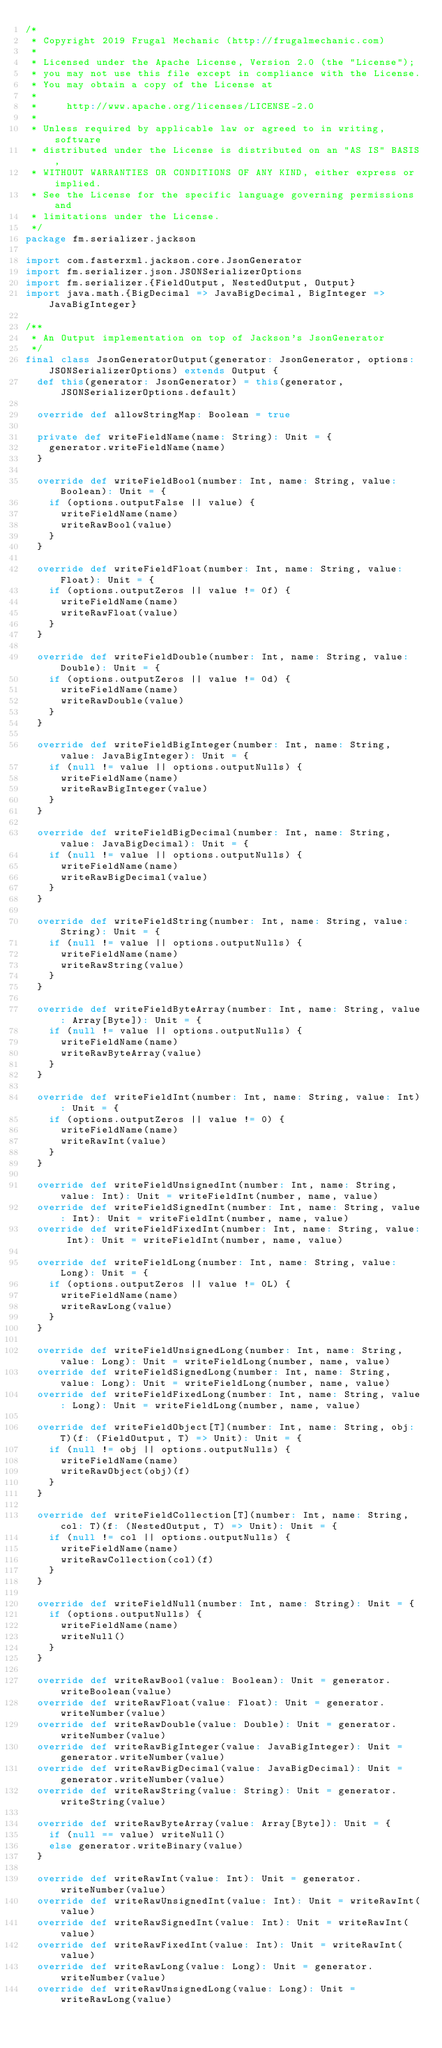Convert code to text. <code><loc_0><loc_0><loc_500><loc_500><_Scala_>/*
 * Copyright 2019 Frugal Mechanic (http://frugalmechanic.com)
 *
 * Licensed under the Apache License, Version 2.0 (the "License");
 * you may not use this file except in compliance with the License.
 * You may obtain a copy of the License at
 *
 *     http://www.apache.org/licenses/LICENSE-2.0
 *
 * Unless required by applicable law or agreed to in writing, software
 * distributed under the License is distributed on an "AS IS" BASIS,
 * WITHOUT WARRANTIES OR CONDITIONS OF ANY KIND, either express or implied.
 * See the License for the specific language governing permissions and
 * limitations under the License.
 */
package fm.serializer.jackson

import com.fasterxml.jackson.core.JsonGenerator
import fm.serializer.json.JSONSerializerOptions
import fm.serializer.{FieldOutput, NestedOutput, Output}
import java.math.{BigDecimal => JavaBigDecimal, BigInteger => JavaBigInteger}

/**
 * An Output implementation on top of Jackson's JsonGenerator
 */
final class JsonGeneratorOutput(generator: JsonGenerator, options: JSONSerializerOptions) extends Output {
  def this(generator: JsonGenerator) = this(generator, JSONSerializerOptions.default)

  override def allowStringMap: Boolean = true

  private def writeFieldName(name: String): Unit = {
    generator.writeFieldName(name)
  }

  override def writeFieldBool(number: Int, name: String, value: Boolean): Unit = {
    if (options.outputFalse || value) {
      writeFieldName(name)
      writeRawBool(value)
    }
  }

  override def writeFieldFloat(number: Int, name: String, value: Float): Unit = {
    if (options.outputZeros || value != 0f) {
      writeFieldName(name)
      writeRawFloat(value)
    }
  }

  override def writeFieldDouble(number: Int, name: String, value: Double): Unit = {
    if (options.outputZeros || value != 0d) {
      writeFieldName(name)
      writeRawDouble(value)
    }
  }

  override def writeFieldBigInteger(number: Int, name: String, value: JavaBigInteger): Unit = {
    if (null != value || options.outputNulls) {
      writeFieldName(name)
      writeRawBigInteger(value)
    }
  }

  override def writeFieldBigDecimal(number: Int, name: String, value: JavaBigDecimal): Unit = {
    if (null != value || options.outputNulls) {
      writeFieldName(name)
      writeRawBigDecimal(value)
    }
  }

  override def writeFieldString(number: Int, name: String, value: String): Unit = {
    if (null != value || options.outputNulls) {
      writeFieldName(name)
      writeRawString(value)
    }
  }

  override def writeFieldByteArray(number: Int, name: String, value: Array[Byte]): Unit = {
    if (null != value || options.outputNulls) {
      writeFieldName(name)
      writeRawByteArray(value)
    }
  }

  override def writeFieldInt(number: Int, name: String, value: Int): Unit = {
    if (options.outputZeros || value != 0) {
      writeFieldName(name)
      writeRawInt(value)
    }
  }

  override def writeFieldUnsignedInt(number: Int, name: String, value: Int): Unit = writeFieldInt(number, name, value)
  override def writeFieldSignedInt(number: Int, name: String, value: Int): Unit = writeFieldInt(number, name, value)
  override def writeFieldFixedInt(number: Int, name: String, value: Int): Unit = writeFieldInt(number, name, value)

  override def writeFieldLong(number: Int, name: String, value: Long): Unit = {
    if (options.outputZeros || value != 0L) {
      writeFieldName(name)
      writeRawLong(value)
    }
  }

  override def writeFieldUnsignedLong(number: Int, name: String, value: Long): Unit = writeFieldLong(number, name, value)
  override def writeFieldSignedLong(number: Int, name: String, value: Long): Unit = writeFieldLong(number, name, value)
  override def writeFieldFixedLong(number: Int, name: String, value: Long): Unit = writeFieldLong(number, name, value)

  override def writeFieldObject[T](number: Int, name: String, obj: T)(f: (FieldOutput, T) => Unit): Unit = {
    if (null != obj || options.outputNulls) {
      writeFieldName(name)
      writeRawObject(obj)(f)
    }
  }

  override def writeFieldCollection[T](number: Int, name: String, col: T)(f: (NestedOutput, T) => Unit): Unit = {
    if (null != col || options.outputNulls) {
      writeFieldName(name)
      writeRawCollection(col)(f)
    }
  }

  override def writeFieldNull(number: Int, name: String): Unit = {
    if (options.outputNulls) {
      writeFieldName(name)
      writeNull()
    }
  }

  override def writeRawBool(value: Boolean): Unit = generator.writeBoolean(value)
  override def writeRawFloat(value: Float): Unit = generator.writeNumber(value)
  override def writeRawDouble(value: Double): Unit = generator.writeNumber(value)
  override def writeRawBigInteger(value: JavaBigInteger): Unit = generator.writeNumber(value)
  override def writeRawBigDecimal(value: JavaBigDecimal): Unit = generator.writeNumber(value)
  override def writeRawString(value: String): Unit = generator.writeString(value)

  override def writeRawByteArray(value: Array[Byte]): Unit = {
    if (null == value) writeNull()
    else generator.writeBinary(value)
  }

  override def writeRawInt(value: Int): Unit = generator.writeNumber(value)
  override def writeRawUnsignedInt(value: Int): Unit = writeRawInt(value)
  override def writeRawSignedInt(value: Int): Unit = writeRawInt(value)
  override def writeRawFixedInt(value: Int): Unit = writeRawInt(value)
  override def writeRawLong(value: Long): Unit = generator.writeNumber(value)
  override def writeRawUnsignedLong(value: Long): Unit = writeRawLong(value)</code> 